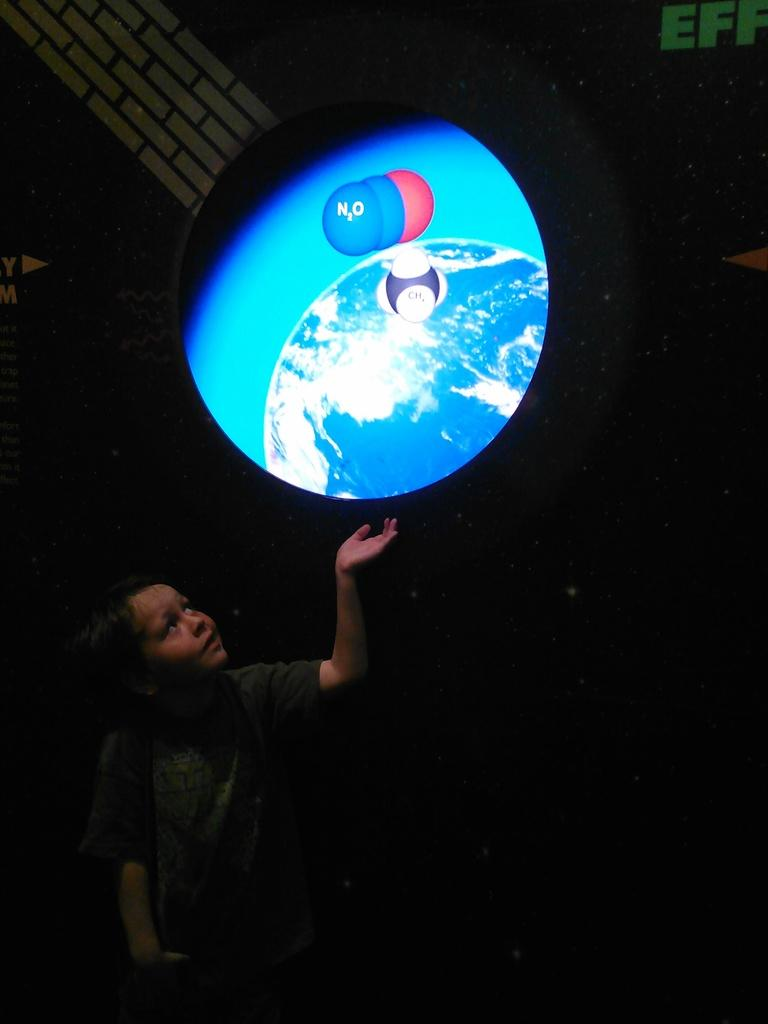What is the main subject in the foreground of the image? There is a kid in the foreground of the image. What is located above the kid in the image? There is an object with animations above the kid in the image. How does the crow interact with the kid in the image? There is no crow present in the image, so it cannot interact with the kid. 